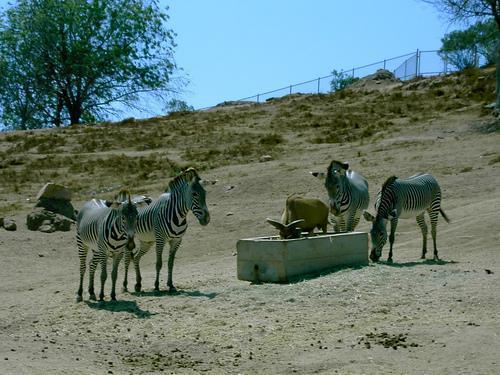How many zebras are depicted?
Give a very brief answer. 4. How many types of animals are walking in the road?
Give a very brief answer. 2. How many zebras?
Give a very brief answer. 4. How many zebras are there?
Give a very brief answer. 4. 